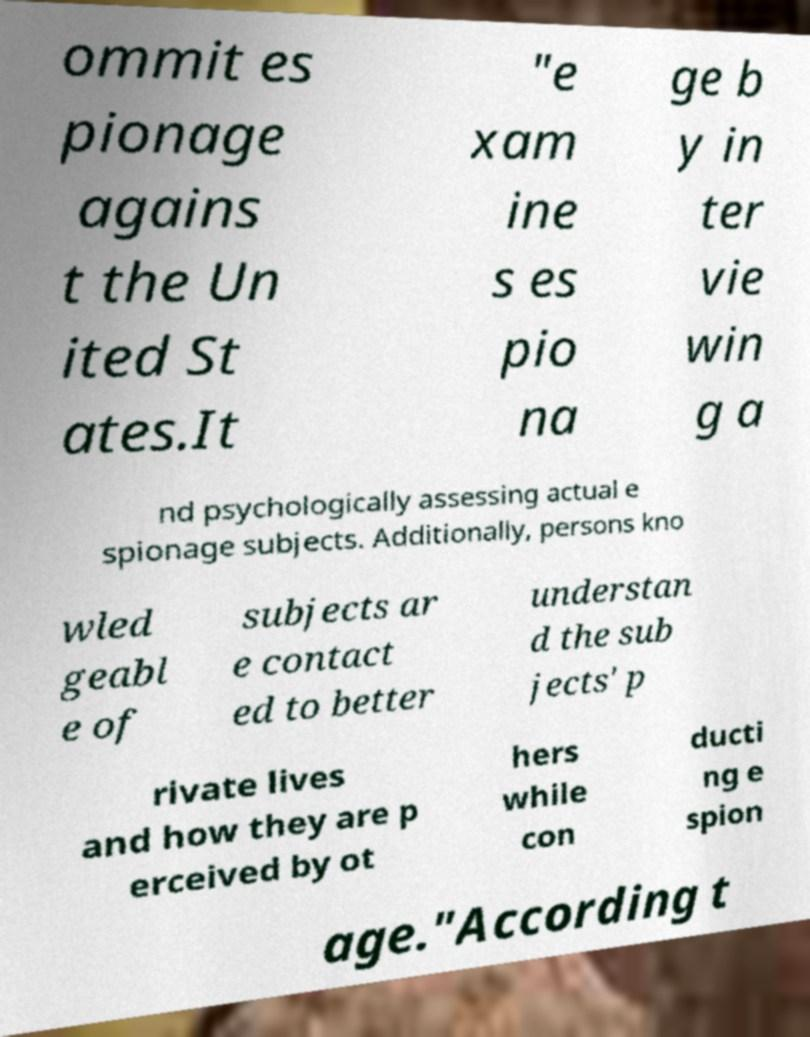For documentation purposes, I need the text within this image transcribed. Could you provide that? ommit es pionage agains t the Un ited St ates.It "e xam ine s es pio na ge b y in ter vie win g a nd psychologically assessing actual e spionage subjects. Additionally, persons kno wled geabl e of subjects ar e contact ed to better understan d the sub jects' p rivate lives and how they are p erceived by ot hers while con ducti ng e spion age."According t 